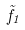Convert formula to latex. <formula><loc_0><loc_0><loc_500><loc_500>\tilde { f } _ { 1 }</formula> 